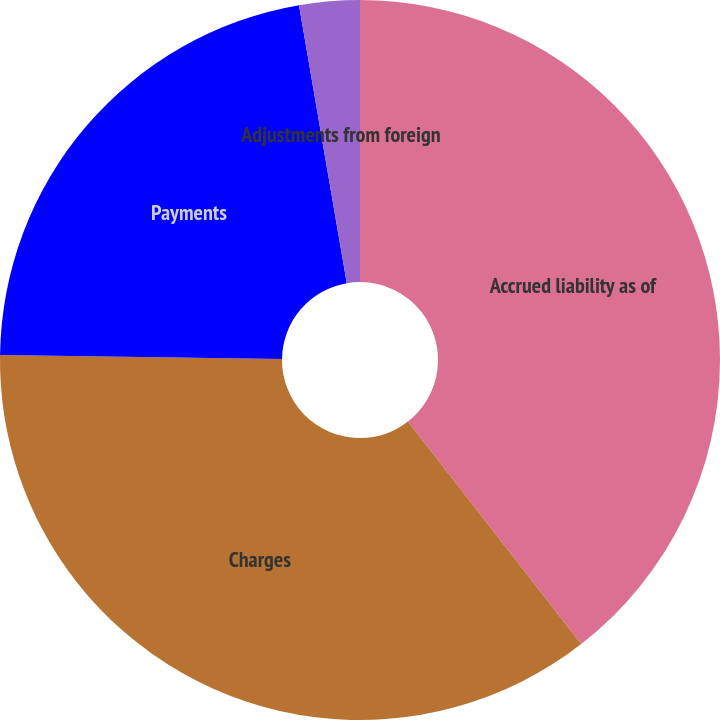<chart> <loc_0><loc_0><loc_500><loc_500><pie_chart><fcel>Accrued liability as of<fcel>Charges<fcel>Payments<fcel>Adjustments from foreign<nl><fcel>39.47%<fcel>35.75%<fcel>22.07%<fcel>2.71%<nl></chart> 